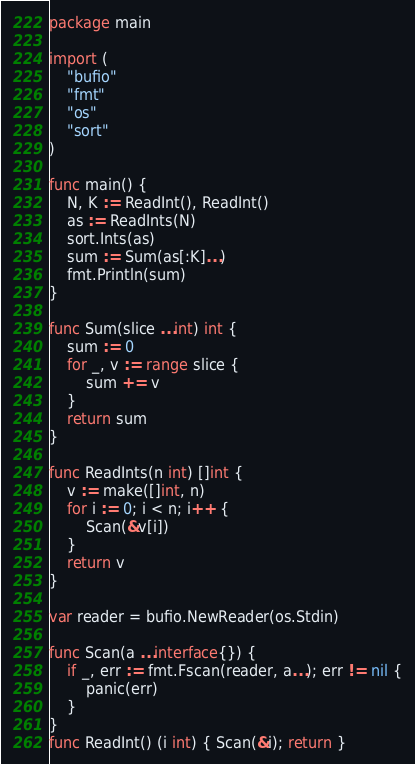<code> <loc_0><loc_0><loc_500><loc_500><_Go_>package main

import (
	"bufio"
	"fmt"
	"os"
	"sort"
)

func main() {
	N, K := ReadInt(), ReadInt()
	as := ReadInts(N)
	sort.Ints(as)
	sum := Sum(as[:K]...)
	fmt.Println(sum)
}

func Sum(slice ...int) int {
	sum := 0
	for _, v := range slice {
		sum += v
	}
	return sum
}

func ReadInts(n int) []int {
	v := make([]int, n)
	for i := 0; i < n; i++ {
		Scan(&v[i])
	}
	return v
}

var reader = bufio.NewReader(os.Stdin)

func Scan(a ...interface{}) {
	if _, err := fmt.Fscan(reader, a...); err != nil {
		panic(err)
	}
}
func ReadInt() (i int) { Scan(&i); return }
</code> 